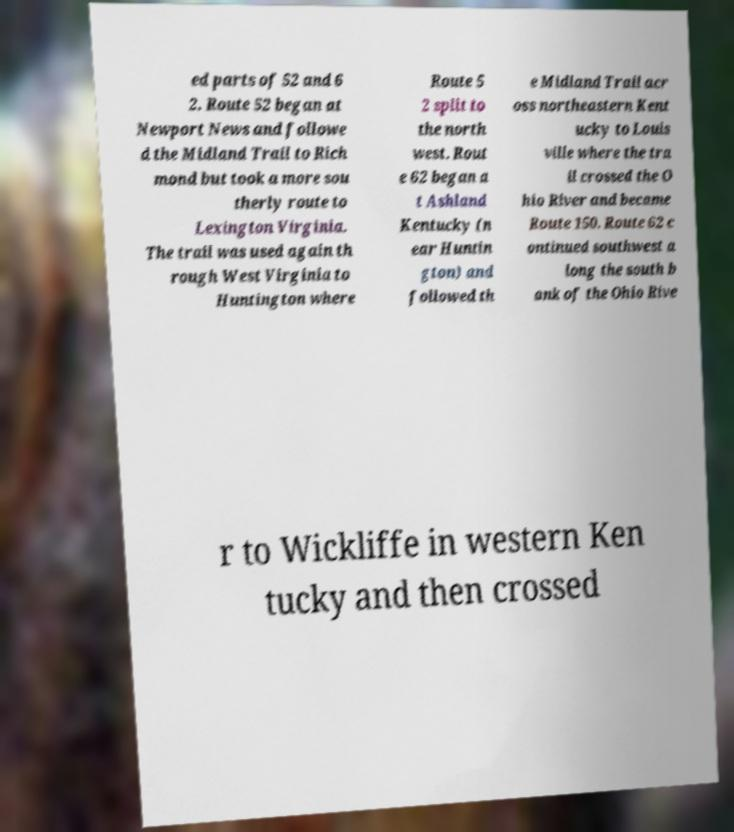Could you extract and type out the text from this image? ed parts of 52 and 6 2. Route 52 began at Newport News and followe d the Midland Trail to Rich mond but took a more sou therly route to Lexington Virginia. The trail was used again th rough West Virginia to Huntington where Route 5 2 split to the north west. Rout e 62 began a t Ashland Kentucky (n ear Huntin gton) and followed th e Midland Trail acr oss northeastern Kent ucky to Louis ville where the tra il crossed the O hio River and became Route 150. Route 62 c ontinued southwest a long the south b ank of the Ohio Rive r to Wickliffe in western Ken tucky and then crossed 